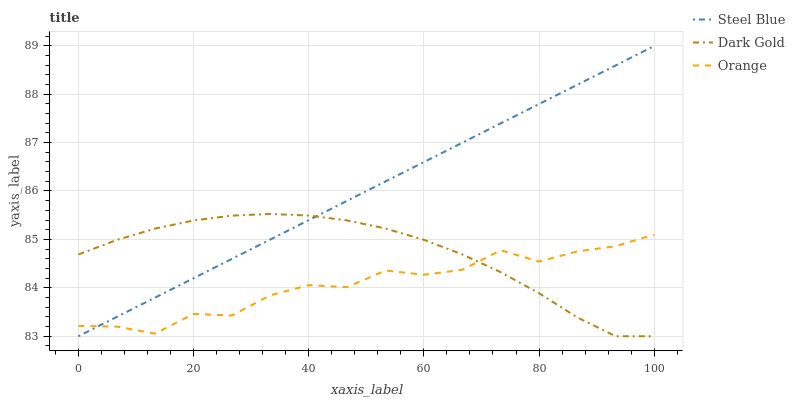Does Orange have the minimum area under the curve?
Answer yes or no. Yes. Does Steel Blue have the maximum area under the curve?
Answer yes or no. Yes. Does Dark Gold have the minimum area under the curve?
Answer yes or no. No. Does Dark Gold have the maximum area under the curve?
Answer yes or no. No. Is Steel Blue the smoothest?
Answer yes or no. Yes. Is Orange the roughest?
Answer yes or no. Yes. Is Dark Gold the smoothest?
Answer yes or no. No. Is Dark Gold the roughest?
Answer yes or no. No. Does Steel Blue have the lowest value?
Answer yes or no. Yes. Does Steel Blue have the highest value?
Answer yes or no. Yes. Does Dark Gold have the highest value?
Answer yes or no. No. Does Orange intersect Dark Gold?
Answer yes or no. Yes. Is Orange less than Dark Gold?
Answer yes or no. No. Is Orange greater than Dark Gold?
Answer yes or no. No. 